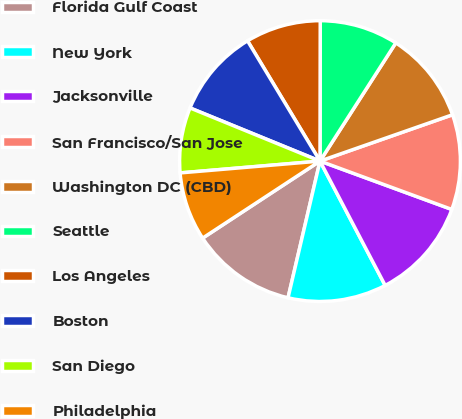Convert chart to OTSL. <chart><loc_0><loc_0><loc_500><loc_500><pie_chart><fcel>Florida Gulf Coast<fcel>New York<fcel>Jacksonville<fcel>San Francisco/San Jose<fcel>Washington DC (CBD)<fcel>Seattle<fcel>Los Angeles<fcel>Boston<fcel>San Diego<fcel>Philadelphia<nl><fcel>12.1%<fcel>11.34%<fcel>11.72%<fcel>10.95%<fcel>10.57%<fcel>9.05%<fcel>8.66%<fcel>10.19%<fcel>7.52%<fcel>7.9%<nl></chart> 